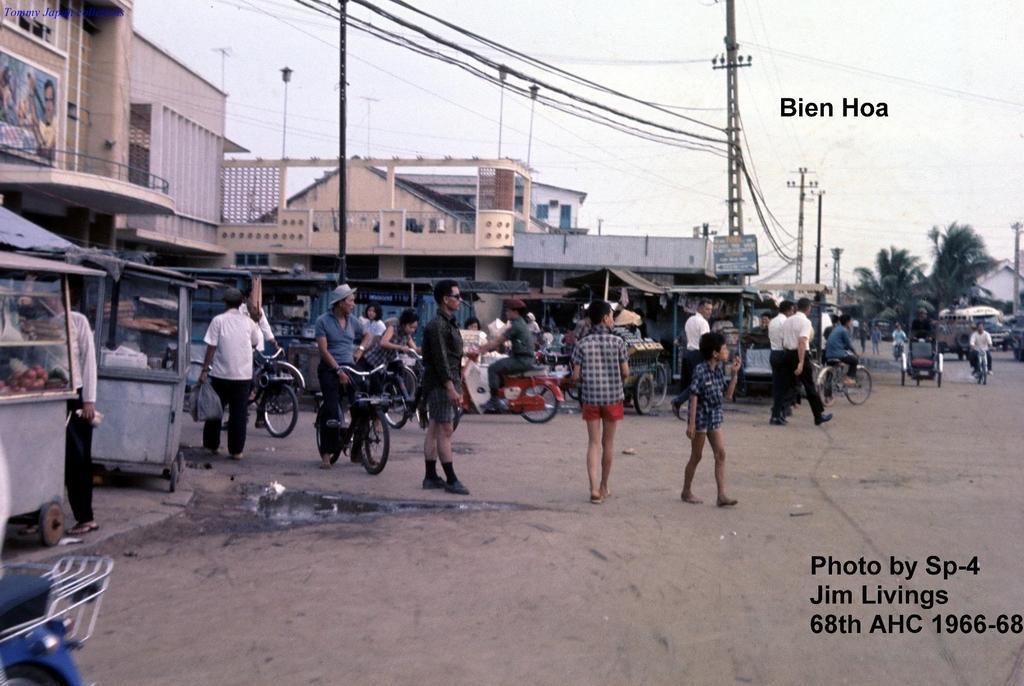In one or two sentences, can you explain what this image depicts? In this picture we can see a group of people are walking on the path and some people are riding their bicycles. Behind the people there are houses, electric poles with cables, trees and a sky. On the image there are watermarks. 